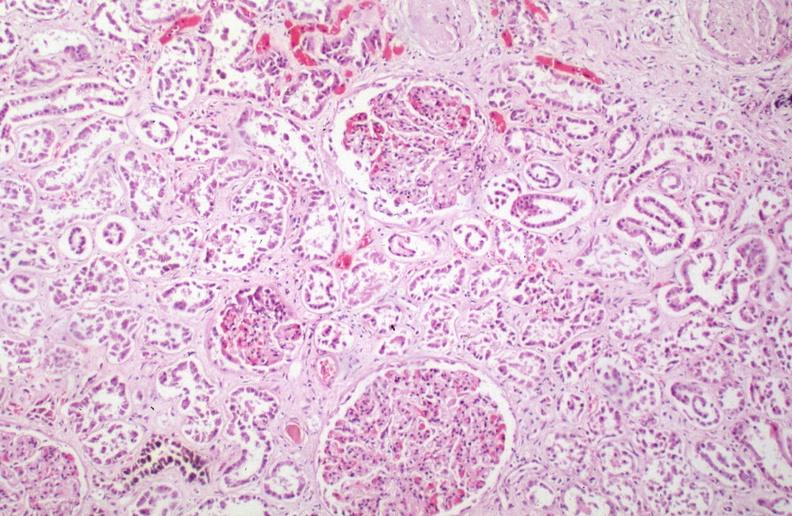does this image show kidney, chronic sickle cell disease?
Answer the question using a single word or phrase. Yes 